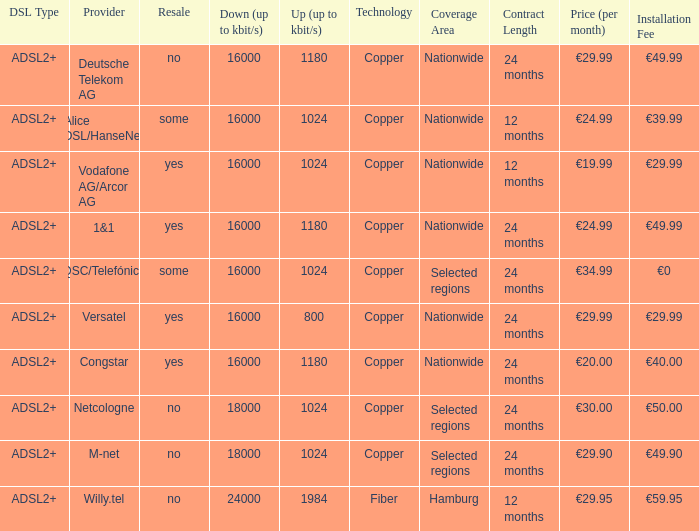What are all the dsl type offered by the M-Net telecom company? ADSL2+. 